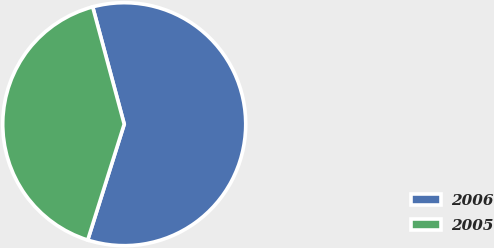Convert chart to OTSL. <chart><loc_0><loc_0><loc_500><loc_500><pie_chart><fcel>2006<fcel>2005<nl><fcel>59.04%<fcel>40.96%<nl></chart> 